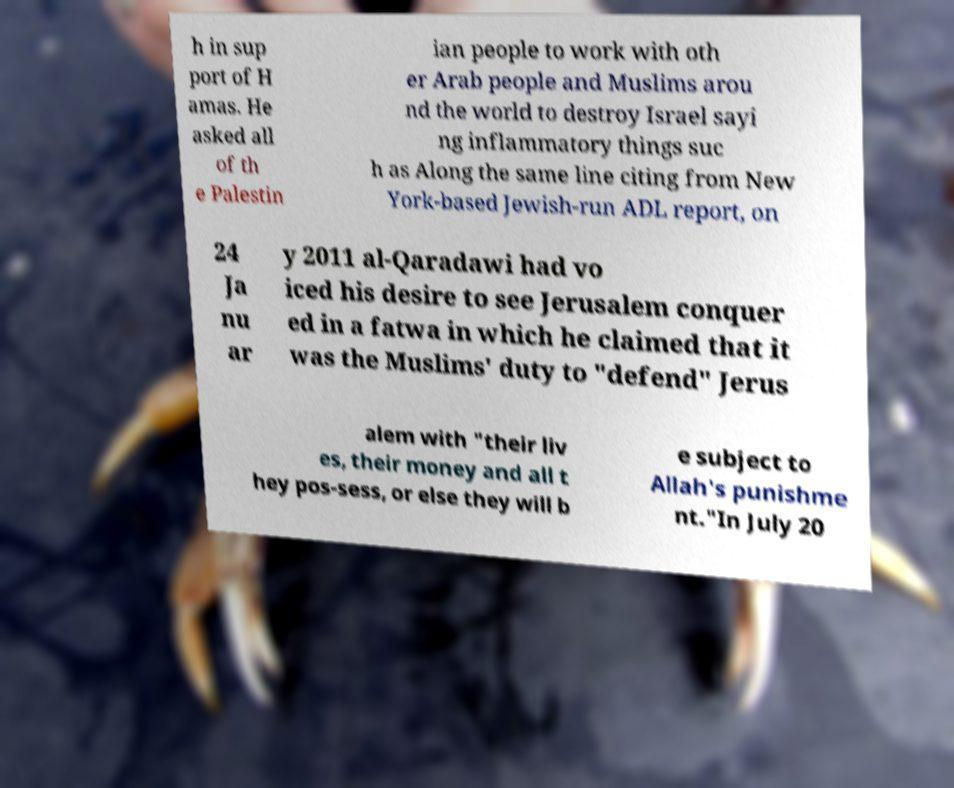Can you read and provide the text displayed in the image?This photo seems to have some interesting text. Can you extract and type it out for me? h in sup port of H amas. He asked all of th e Palestin ian people to work with oth er Arab people and Muslims arou nd the world to destroy Israel sayi ng inflammatory things suc h as Along the same line citing from New York-based Jewish-run ADL report, on 24 Ja nu ar y 2011 al-Qaradawi had vo iced his desire to see Jerusalem conquer ed in a fatwa in which he claimed that it was the Muslims' duty to "defend" Jerus alem with "their liv es, their money and all t hey pos-sess, or else they will b e subject to Allah's punishme nt."In July 20 